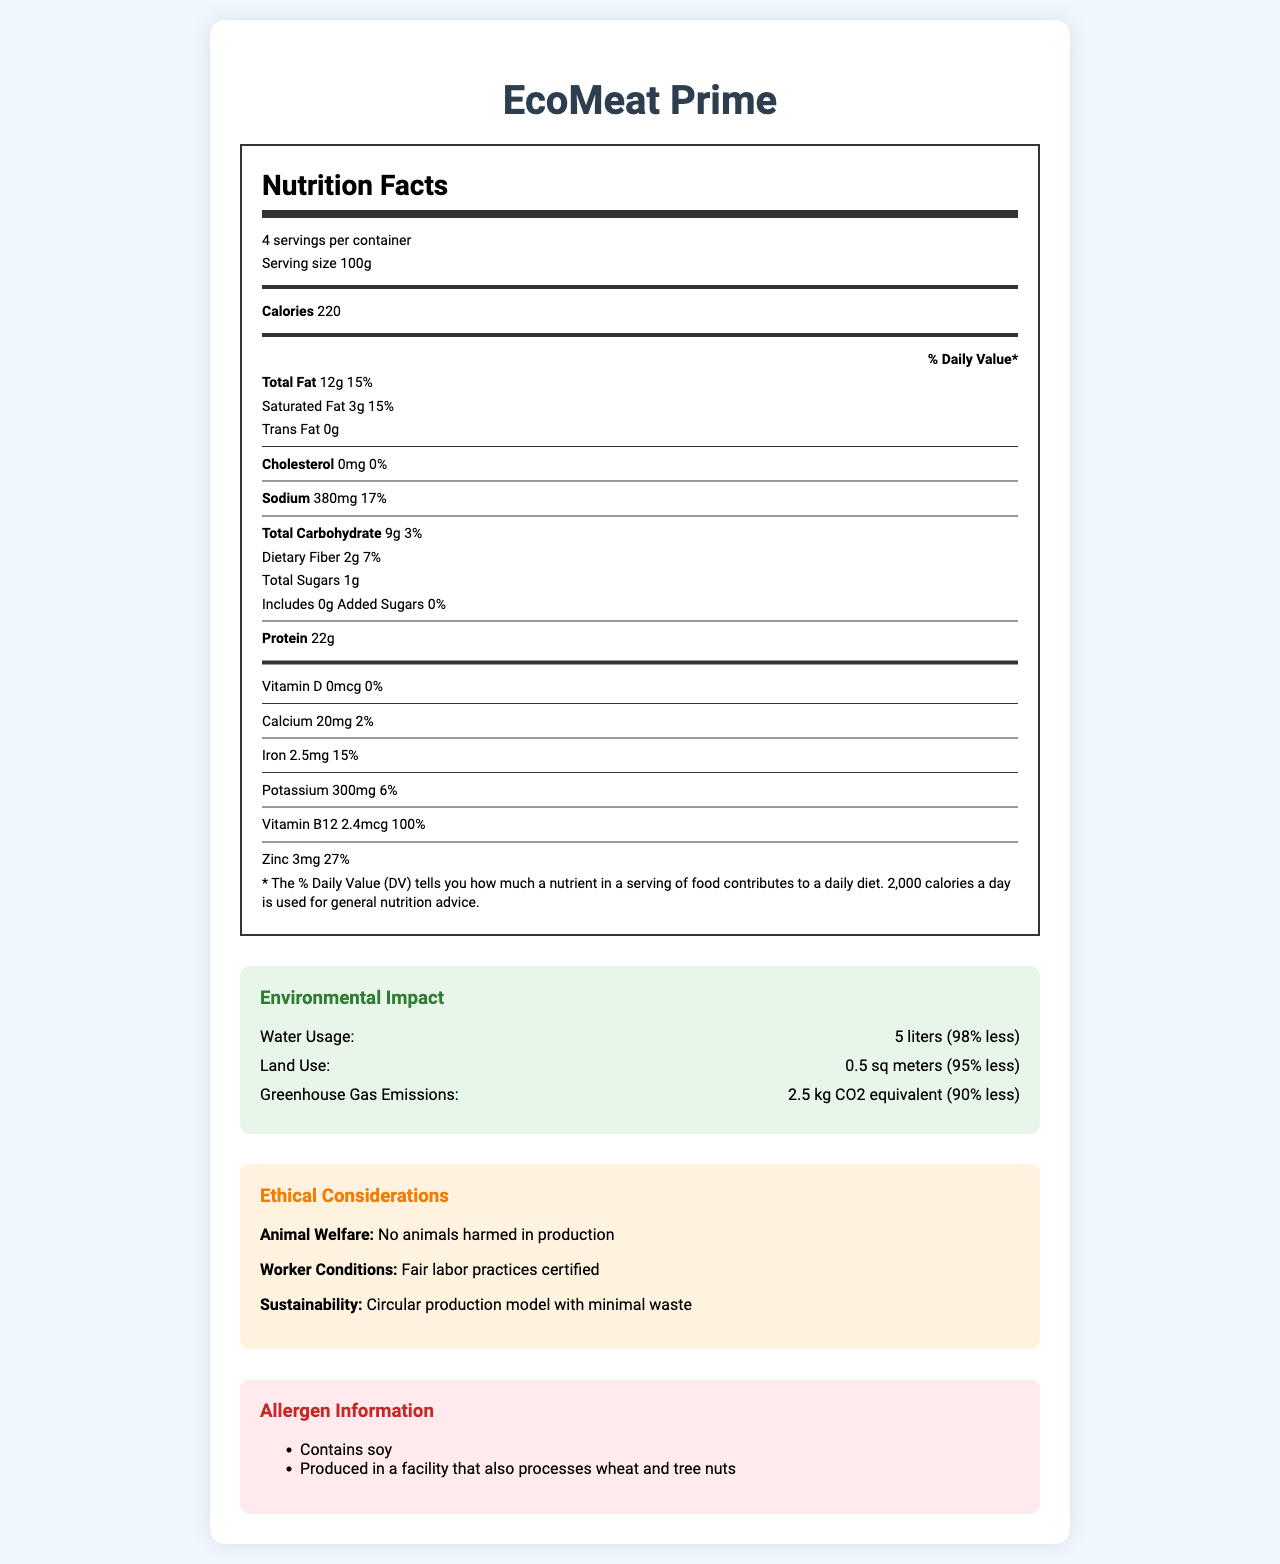what is the serving size for EcoMeat Prime? The serving size is explicitly mentioned as 100g in the document.
Answer: 100g how many servings are there per container? The document states that there are 4 servings per container.
Answer: 4 how much protein does one serving of EcoMeat Prime provide? The protein content per serving is listed as 22g in the Nutrition Facts.
Answer: 22g what is the percentage of daily value for sodium in one serving? The percent daily value for sodium is given as 17% in the Nutrition Facts.
Answer: 17% what is the total fat content in one serving, and its daily value percentage? The total fat content per serving is 12g and the daily value percentage is 15%, as specified in the Nutrition Facts.
Answer: 12g, 15% does EcoMeat Prime contain any cholesterol? The document shows that EcoMeat Prime contains 0mg of cholesterol, which equates to 0% of the daily value.
Answer: No what are the environmental benefits of EcoMeat Prime compared to conventional beef? (choose the best answer) A. Less water usage, more land use, fewer greenhouse gases B. More water usage, less land use, fewer greenhouse gases C. Less water usage, less land use, fewer greenhouse gases D. More water usage, more land use, fewer greenhouse gases EcoMeat Prime uses 98% less water, 95% less land, and generates 90% less greenhouse gas emissions compared to conventional beef.
Answer: C which of the following nutrients does EcoMeat Prime provide more than 25% of daily value? I. Vitamin B12 II. Iron III. Zinc IV. Dietary Fiber EcoMeat Prime provides 100% of Vitamin B12 and 27% of Zinc daily value, which are both more than 25%.
Answer: I, III is there added sugar in EcoMeat Prime? The document specifies that there are 0g of added sugars per serving.
Answer: No summarize the main idea of the document. The document includes nutritional specifics such as calorie content, macronutrients, vitamins, and minerals. Additionally, it highlights the environmental advantages of EcoMeat Prime over conventional beef, as well as ethical production practices and potential allergens.
Answer: The document is a detailed Nutrition Facts label for EcoMeat Prime, a lab-grown meat alternative, providing nutritional information, environmental impact data, ethical considerations, allergen information, production method, and shelf life. how much does EcoMeat Prime contribute to daily iron intake? The iron content in one serving is 2.5mg, equating to 15% of the daily value.
Answer: 15% what are the components of the ethical considerations for EcoMeat Prime? The document lists animal welfare (no harm to animals), fair labor practices for workers, and a sustainable circular production model as the ethical considerations.
Answer: Animal welfare, worker conditions, sustainability from what production method is EcoMeat Prime derived? The production method is specified as lab-grown using stem cell cultivation and tissue engineering techniques in the document.
Answer: Lab-grown using stem cell cultivation and tissue engineering techniques is the genetic modification status of EcoMeat Prime GMO or Non-GMO? The document clearly states that EcoMeat Prime is Non-GMO, produced using precision fermentation of non-genetically modified yeast strains.
Answer: Non-GMO based on the document, does EcoMeat Prime contain wheat allergens directly in the product? The document states that EcoMeat Prime is produced in a facility that also processes wheat, but it does not specifically list wheat as an ingredient in the product itself.
Answer: No how long can EcoMeat Prime be stored when frozen? The shelf life of EcoMeat Prime is mentioned as 6 months when frozen.
Answer: 6 months describe the taste profile of EcoMeat Prime. The document describes that the taste profile is designed to closely replicate that of ground beef.
Answer: Engineered to closely mimic the flavor and texture of ground beef does EcoMeat Prime's production involve any animals in the process? The ethical considerations section indicates that no animals are harmed in the production of EcoMeat Prime.
Answer: No what is the total calorie count for an entire container of EcoMeat Prime? Since the container has 4 servings and each serving contains 220 calories, the total calorie count is 4 × 220 = 880 calories.
Answer: 880 calories what is the source of genetic modification for the yeast strains used in EcoMeat Prime's production? The document specifies that the yeast strains are non-genetically modified, but does not provide detailed information on their sourcing.
Answer: Not enough information 